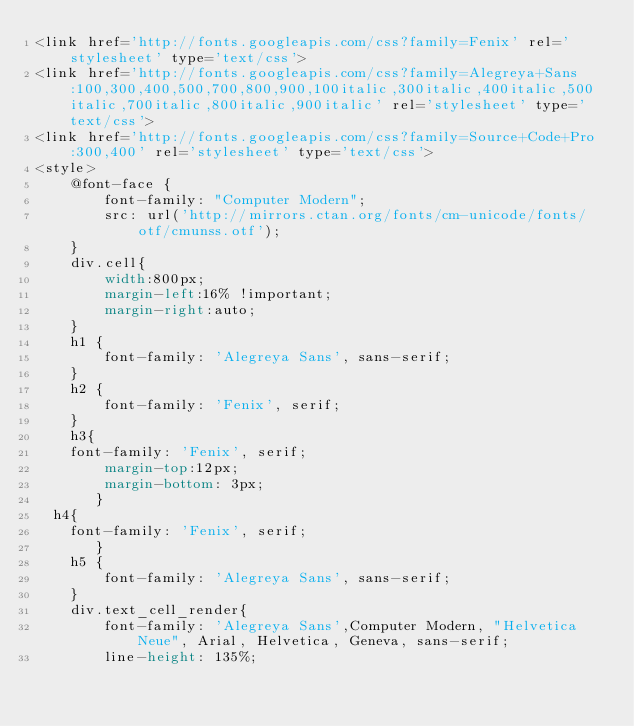<code> <loc_0><loc_0><loc_500><loc_500><_CSS_><link href='http://fonts.googleapis.com/css?family=Fenix' rel='stylesheet' type='text/css'>
<link href='http://fonts.googleapis.com/css?family=Alegreya+Sans:100,300,400,500,700,800,900,100italic,300italic,400italic,500italic,700italic,800italic,900italic' rel='stylesheet' type='text/css'>
<link href='http://fonts.googleapis.com/css?family=Source+Code+Pro:300,400' rel='stylesheet' type='text/css'>
<style>
    @font-face {
        font-family: "Computer Modern";
        src: url('http://mirrors.ctan.org/fonts/cm-unicode/fonts/otf/cmunss.otf');
    }
    div.cell{
        width:800px;
        margin-left:16% !important;
        margin-right:auto;
    }
    h1 {
        font-family: 'Alegreya Sans', sans-serif;
    }
    h2 {
        font-family: 'Fenix', serif;
    }
    h3{
		font-family: 'Fenix', serif;
        margin-top:12px;
        margin-bottom: 3px;
       }
	h4{
		font-family: 'Fenix', serif;
       }
    h5 {
        font-family: 'Alegreya Sans', sans-serif;
    }	   
    div.text_cell_render{
        font-family: 'Alegreya Sans',Computer Modern, "Helvetica Neue", Arial, Helvetica, Geneva, sans-serif;
        line-height: 135%;</code> 